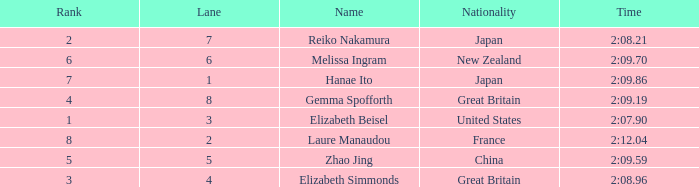What is Laure Manaudou's highest rank? 8.0. 